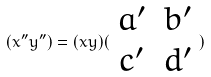<formula> <loc_0><loc_0><loc_500><loc_500>( x ^ { \prime \prime } y ^ { \prime \prime } ) = ( x y ) ( \begin{array} { c c } a ^ { \prime } & b ^ { \prime } \\ c ^ { \prime } & d ^ { \prime } \end{array} )</formula> 